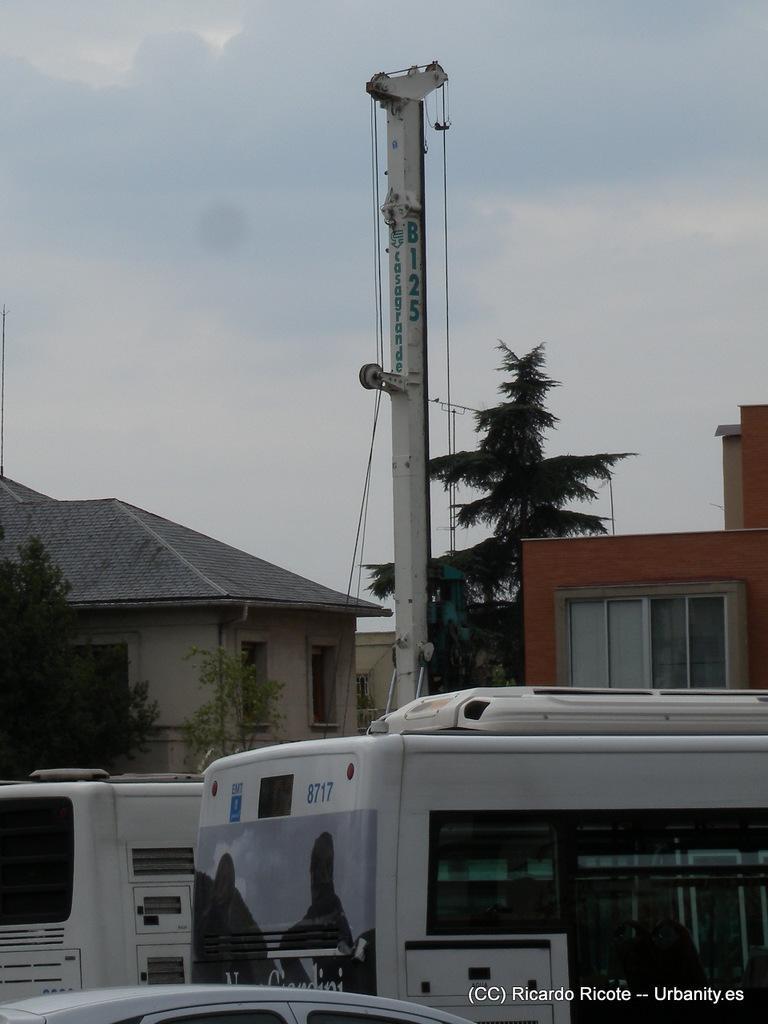Could you give a brief overview of what you see in this image? In this image I can see few white color vehicles and on these vehicles I can see something is written. In the background I can see few buildings, few trees, a pole, few wires and sky. 